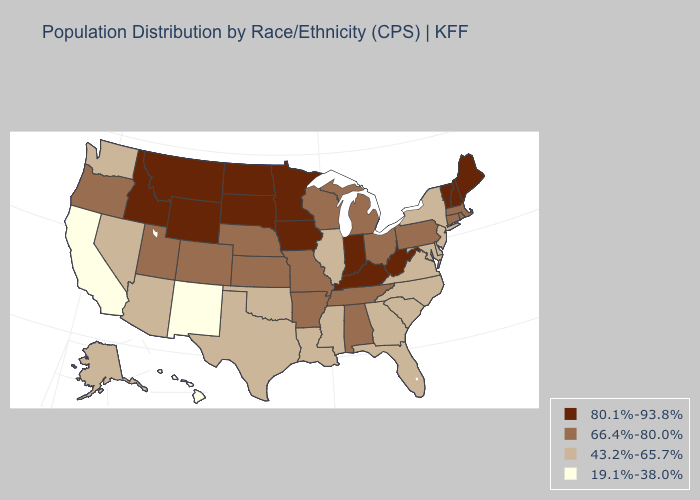What is the lowest value in the MidWest?
Answer briefly. 43.2%-65.7%. Which states have the highest value in the USA?
Concise answer only. Idaho, Indiana, Iowa, Kentucky, Maine, Minnesota, Montana, New Hampshire, North Dakota, South Dakota, Vermont, West Virginia, Wyoming. Name the states that have a value in the range 66.4%-80.0%?
Be succinct. Alabama, Arkansas, Colorado, Connecticut, Kansas, Massachusetts, Michigan, Missouri, Nebraska, Ohio, Oregon, Pennsylvania, Rhode Island, Tennessee, Utah, Wisconsin. What is the value of Tennessee?
Answer briefly. 66.4%-80.0%. Name the states that have a value in the range 80.1%-93.8%?
Answer briefly. Idaho, Indiana, Iowa, Kentucky, Maine, Minnesota, Montana, New Hampshire, North Dakota, South Dakota, Vermont, West Virginia, Wyoming. Does Georgia have a higher value than Hawaii?
Give a very brief answer. Yes. Which states hav the highest value in the West?
Short answer required. Idaho, Montana, Wyoming. Among the states that border Massachusetts , does New Hampshire have the lowest value?
Give a very brief answer. No. How many symbols are there in the legend?
Be succinct. 4. What is the lowest value in the South?
Answer briefly. 43.2%-65.7%. What is the value of New Hampshire?
Quick response, please. 80.1%-93.8%. Does the map have missing data?
Keep it brief. No. Name the states that have a value in the range 19.1%-38.0%?
Give a very brief answer. California, Hawaii, New Mexico. Does New Mexico have the lowest value in the West?
Write a very short answer. Yes. 